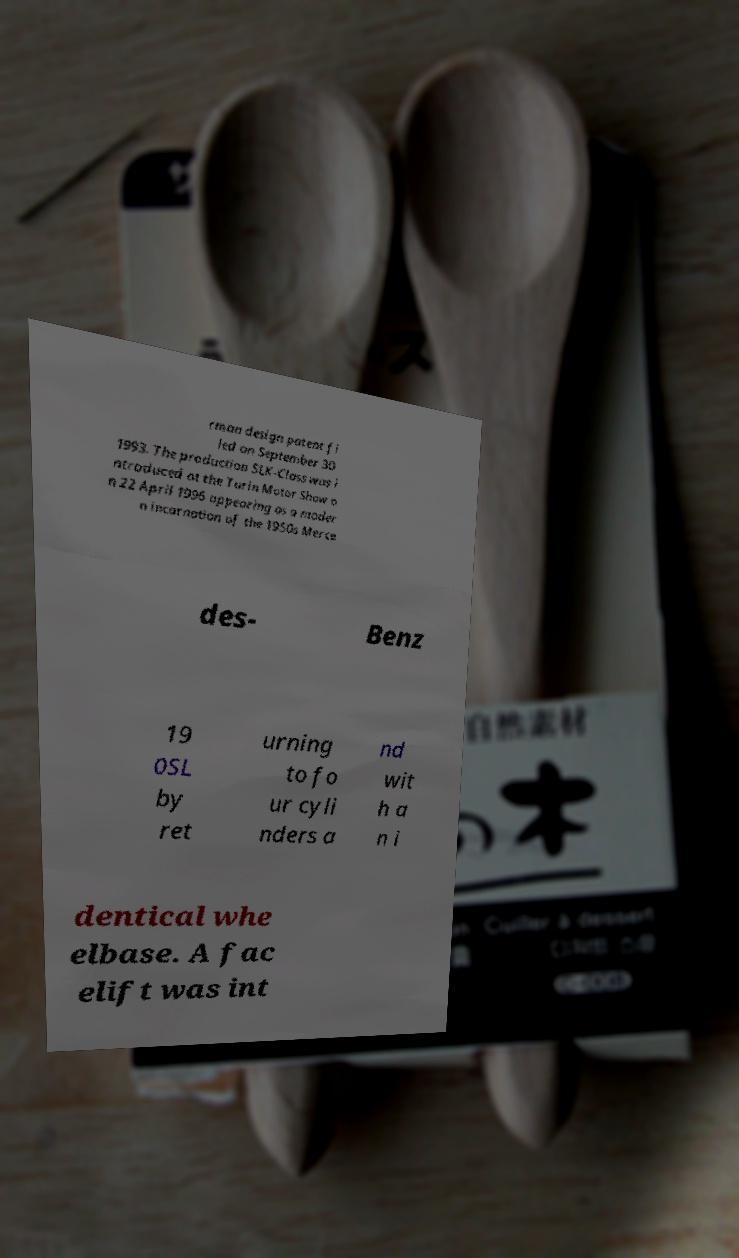Please identify and transcribe the text found in this image. rman design patent fi led on September 30 1993. The production SLK-Class was i ntroduced at the Turin Motor Show o n 22 April 1996 appearing as a moder n incarnation of the 1950s Merce des- Benz 19 0SL by ret urning to fo ur cyli nders a nd wit h a n i dentical whe elbase. A fac elift was int 